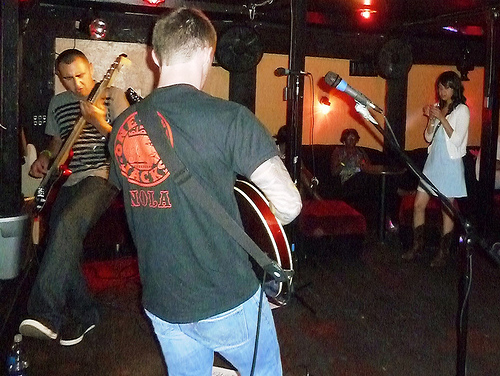<image>
Can you confirm if the guitar is on the man? No. The guitar is not positioned on the man. They may be near each other, but the guitar is not supported by or resting on top of the man. Is there a shirt behind the microphone? No. The shirt is not behind the microphone. From this viewpoint, the shirt appears to be positioned elsewhere in the scene. 